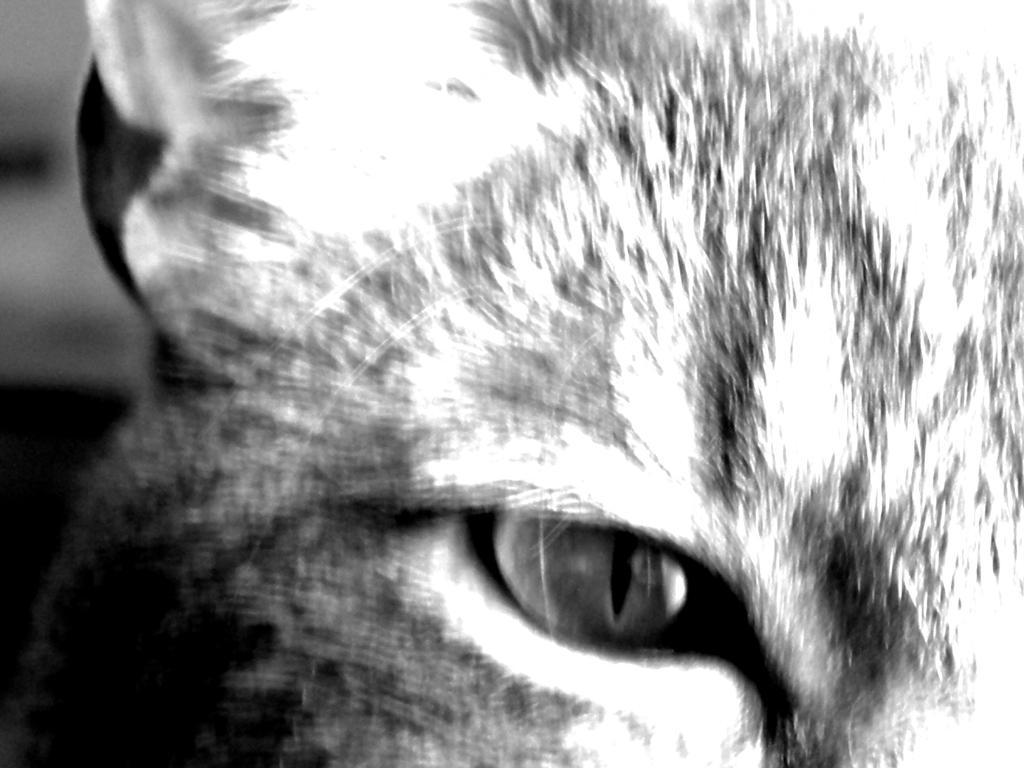Please provide a concise description of this image. It is a black and white picture. In this image, we can see an animal. 